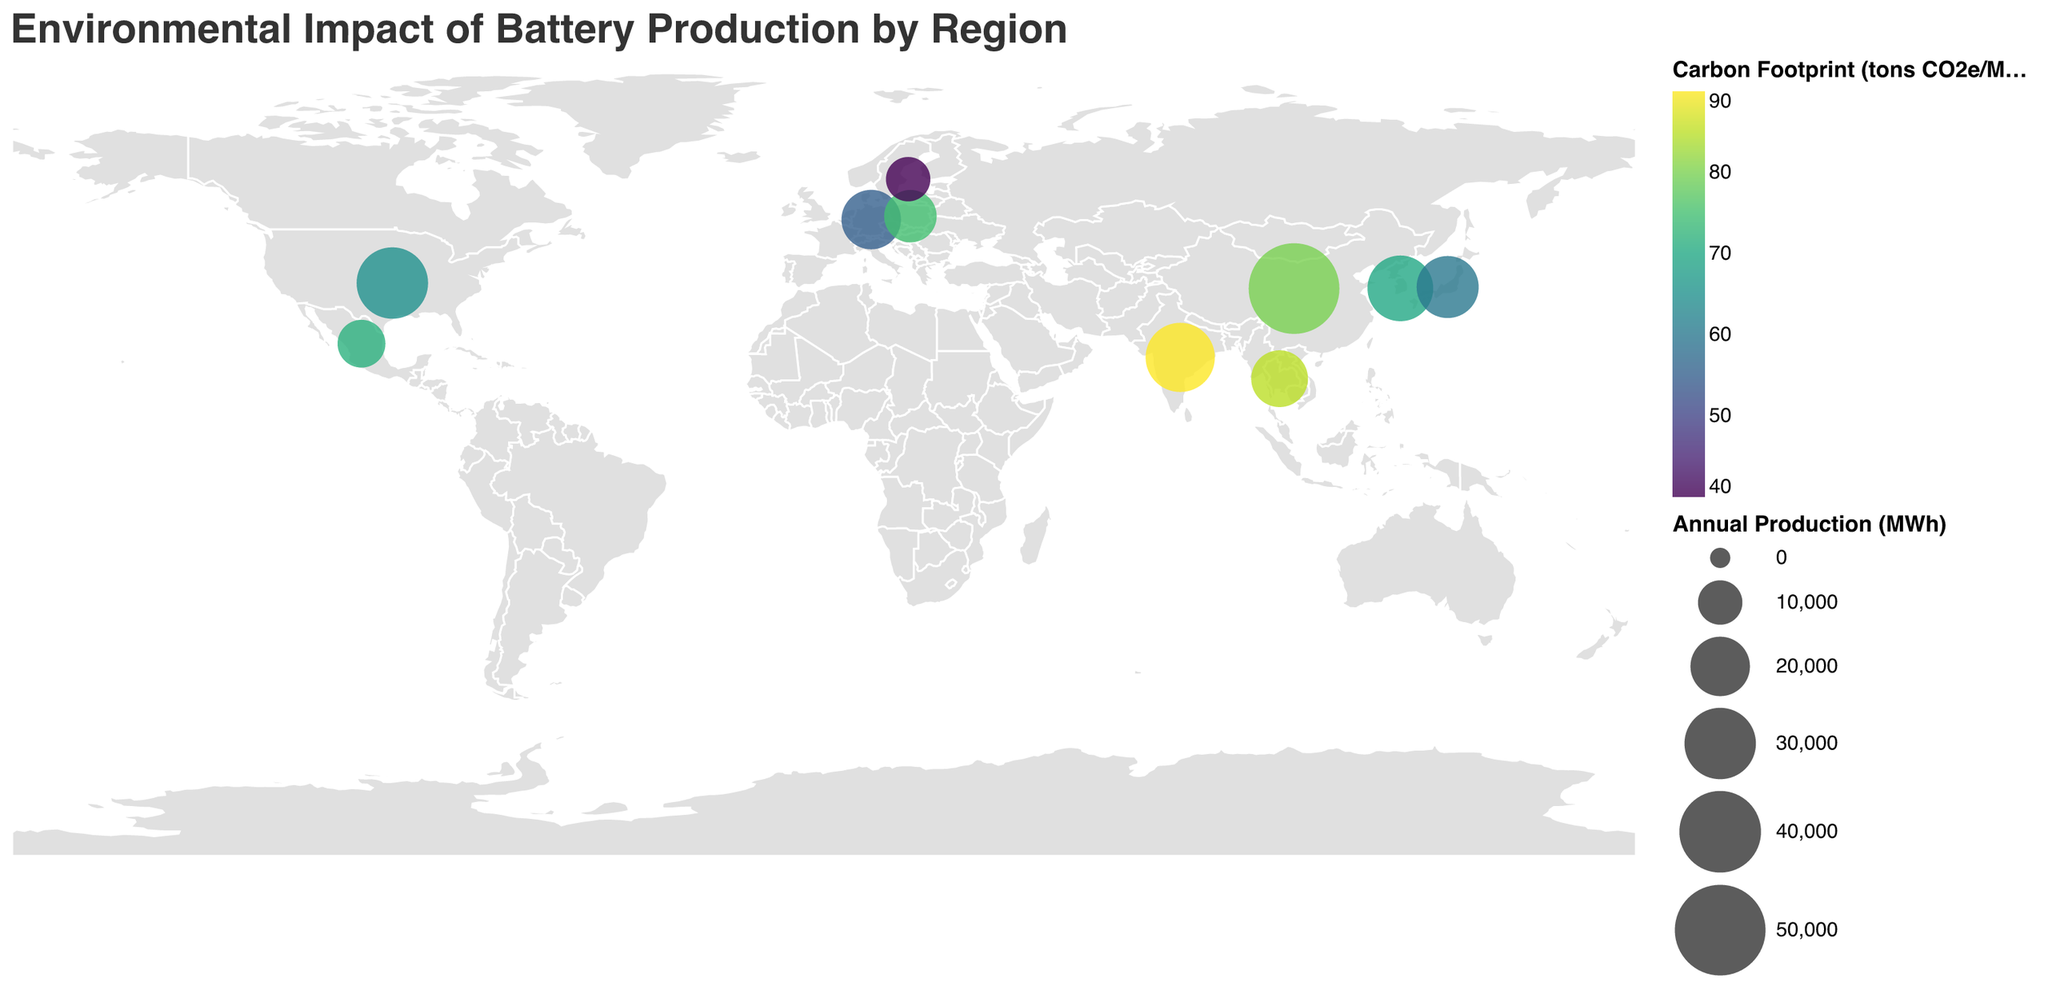Which region has the highest carbon footprint in tons CO2e/MWh? Look at the color legend for "Carbon Footprint (tons CO2e/MWh)" and find the region colored the darkest. India's footprint is highest at 90 tons CO2e/MWh.
Answer: India Which region produces the least waste in kg/MWh? Refer to the tooltip and find the region with the lowest "Waste Generation (kg/MWh)". Sweden generates the least waste at 80 kg/MWh.
Answer: Sweden Between China and the United States, which region has a higher annual production in MWh? Compare the sizes of the circles representing China and the United States. China's circle is larger, indicating higher annual production.
Answer: China Which region has the lowest carbon footprint, and what is its value? Refer to the tooltip and find the region with the lowest "Carbon Footprint (tons CO2e/MWh)". Sweden has the lowest value at 40 tons CO2e/MWh.
Answer: Sweden, 40 What is the total annual production of batteries for Germany and South Korea combined? Add the Annual Production (MWh) values for Germany and South Korea: 20,000 + 25,000 = 45,000.
Answer: 45,000 Which region has the second highest waste generation? Sort the values of "Waste Generation (kg/MWh)" and find the second highest. Thailand has the second highest at 160 kg/MWh.
Answer: Thailand How does the waste generation in Japan compare to that in Germany? Compare the "Waste Generation (kg/MWh)" values for Japan (110 kg/MWh) and Germany (100 kg/MWh). Japan's waste generation is higher by 10 kg/MWh.
Answer: Japan is higher by 10 kg/MWh Which region has a higher carbon footprint per MWh, Mexico or Poland? Compare the "Carbon Footprint (tons CO2e/MWh)" for Mexico (72) and Poland (75). Poland's carbon footprint is higher.
Answer: Poland What is the average carbon footprint across all regions? Sum all carbon footprints and divide by the number of regions: (80 + 65 + 55 + 70 + 60 + 75 + 40 + 85 + 72 + 90)/10 = 69.2 tons CO2e/MWh.
Answer: 69.2 Which region's carbon footprint is closest to the average value? The average is 69.2, compare each region's footprint to find the closest. Both Mexico and South Korea (72 and 70) are close, but South Korea is slightly closer.
Answer: South Korea 